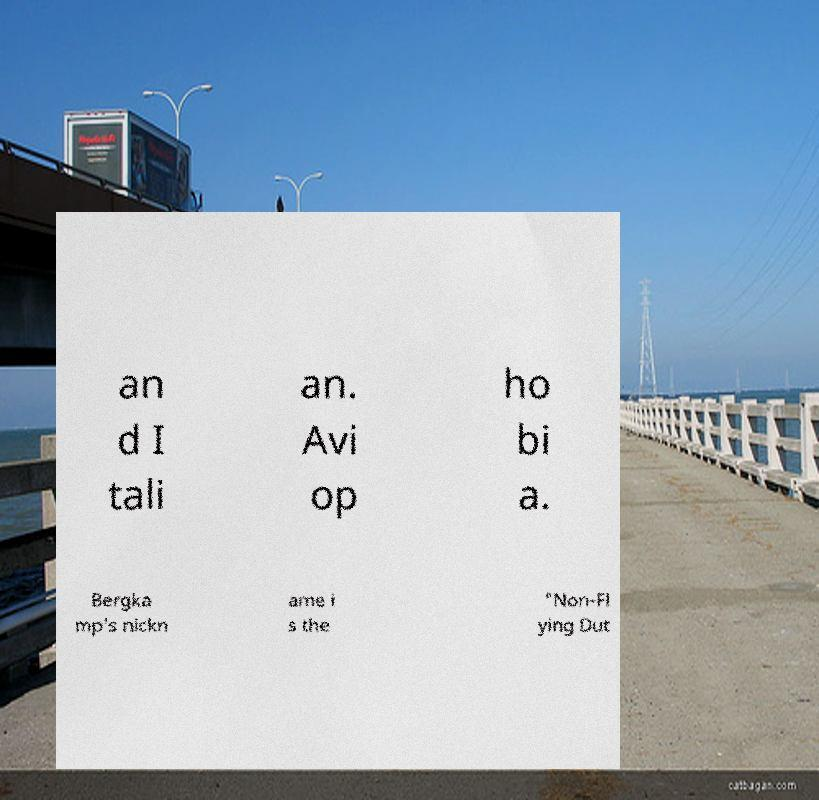Please identify and transcribe the text found in this image. an d I tali an. Avi op ho bi a. Bergka mp's nickn ame i s the "Non-Fl ying Dut 